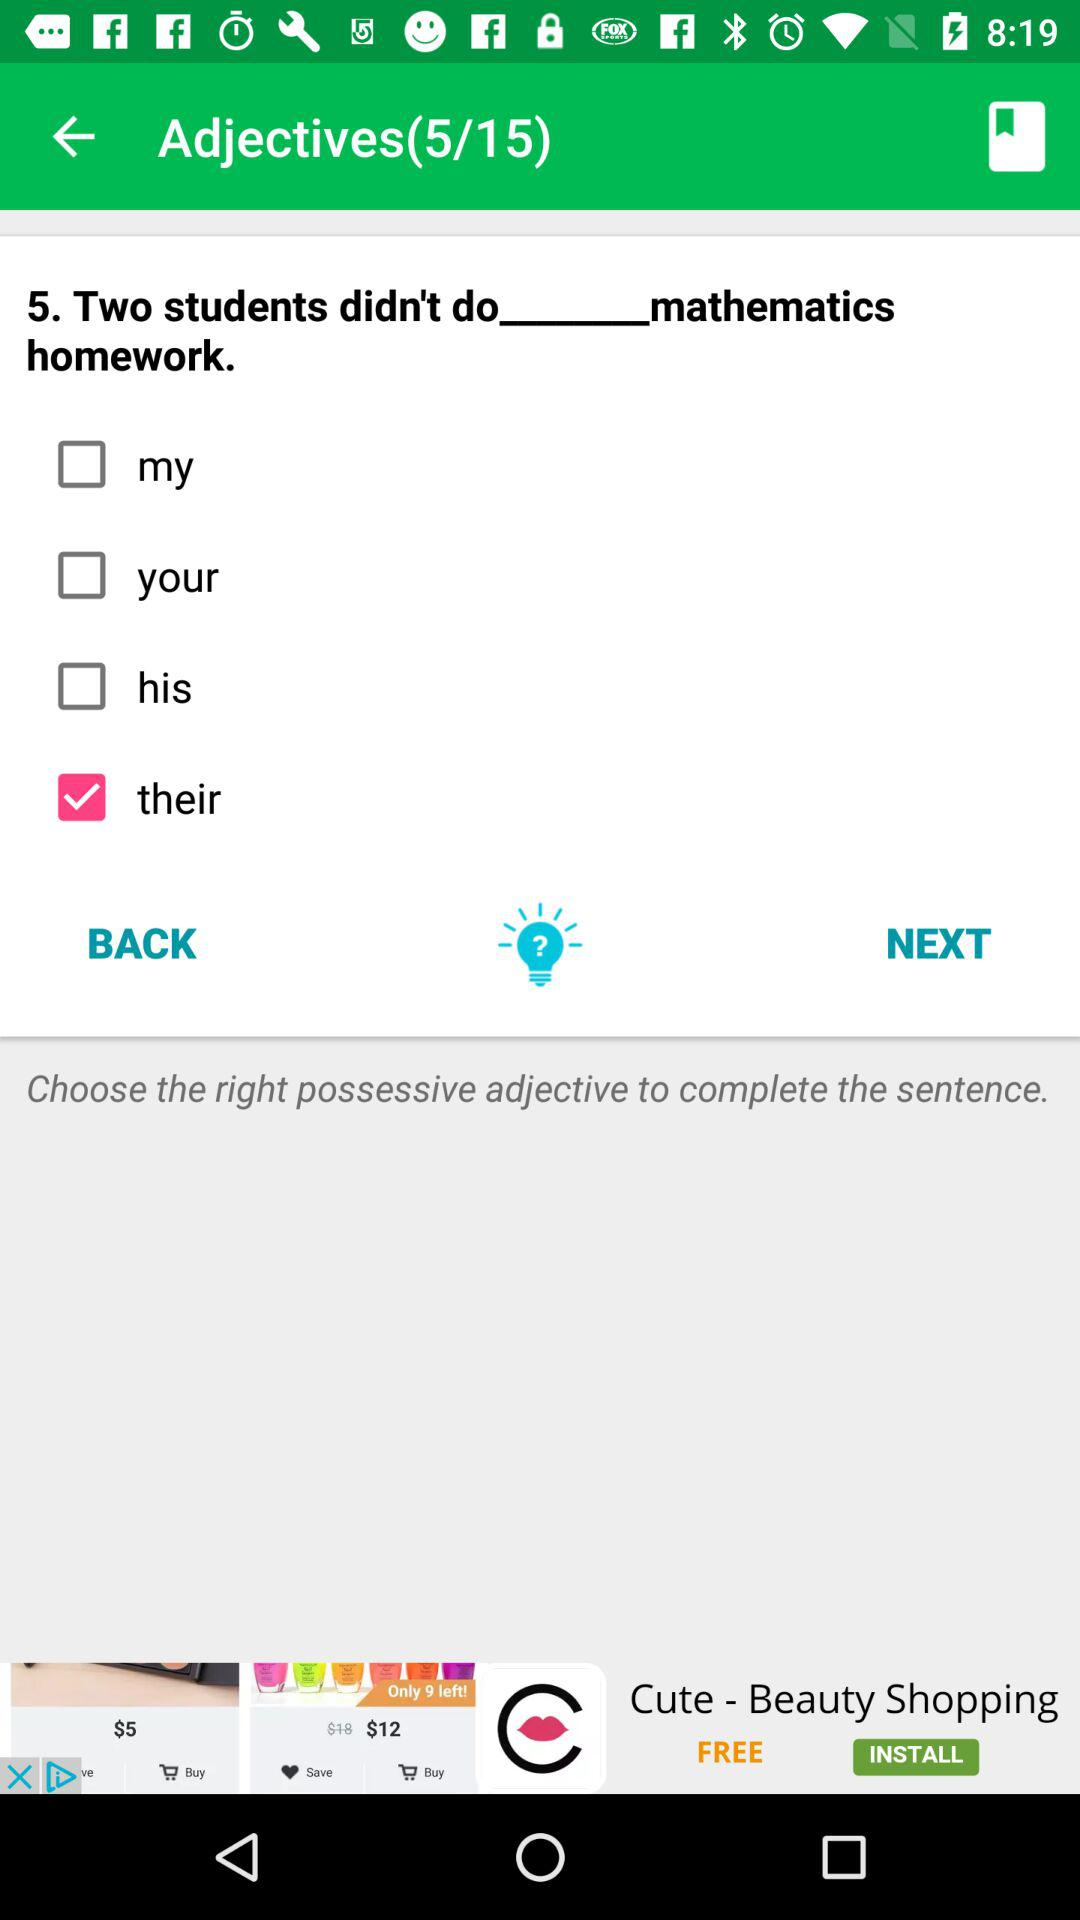What is the purpose of the exercise shown in the image? The exercise aims to enhance the learner's understanding of possessive adjectives in English. It presents a sentence with a blank where the student must select the appropriate possessive adjective to correctly complete the statement.  Can you tell me more about possessive adjectives? Certainly! Possessive adjectives are used to show ownership or a relationship to something. Common examples include 'my,' 'your,' 'his,' 'her,' 'its,' 'our,' and 'their.' Each one corresponds to different pronouns and nouns to express who owns or is related to the described object in the context of a sentence. 